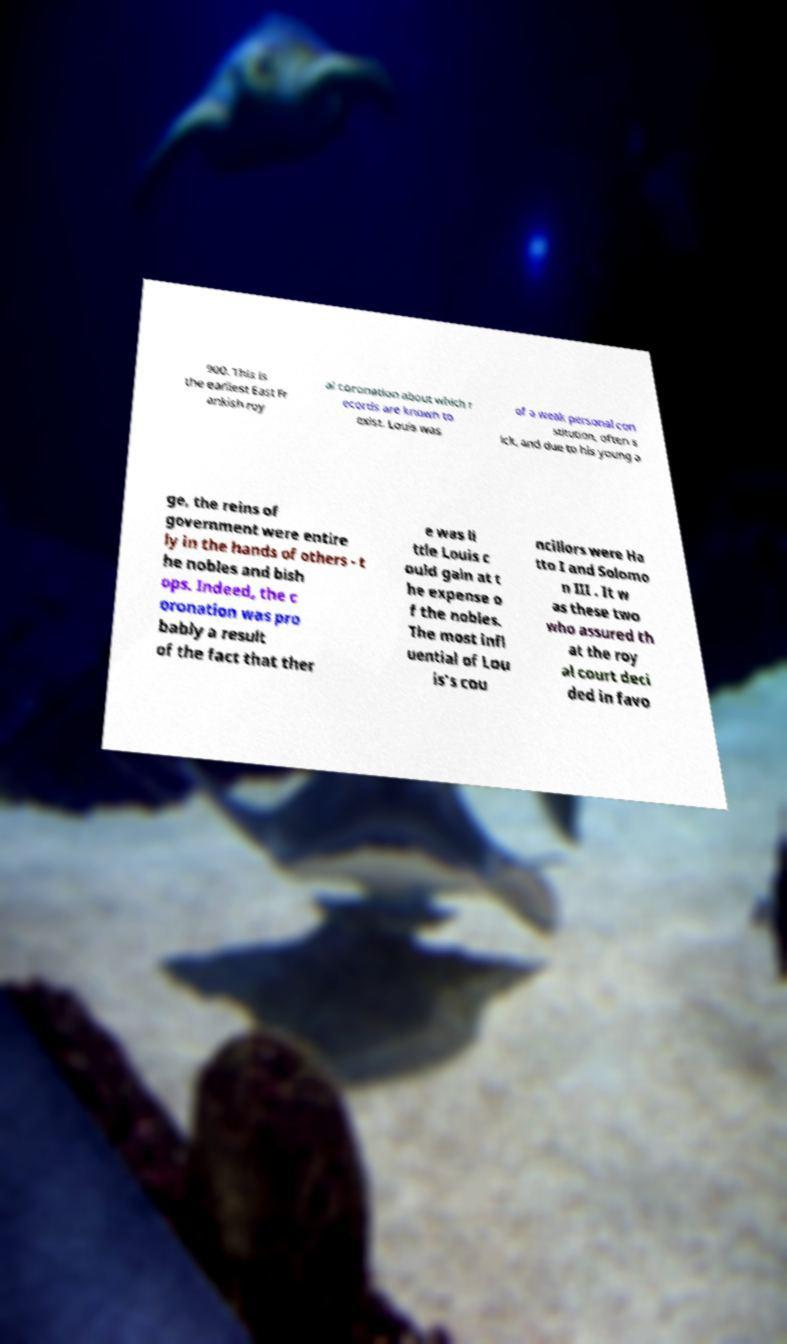There's text embedded in this image that I need extracted. Can you transcribe it verbatim? 900. This is the earliest East Fr ankish roy al coronation about which r ecords are known to exist. Louis was of a weak personal con stitution, often s ick, and due to his young a ge, the reins of government were entire ly in the hands of others - t he nobles and bish ops. Indeed, the c oronation was pro bably a result of the fact that ther e was li ttle Louis c ould gain at t he expense o f the nobles. The most infl uential of Lou is's cou ncillors were Ha tto I and Solomo n III . It w as these two who assured th at the roy al court deci ded in favo 